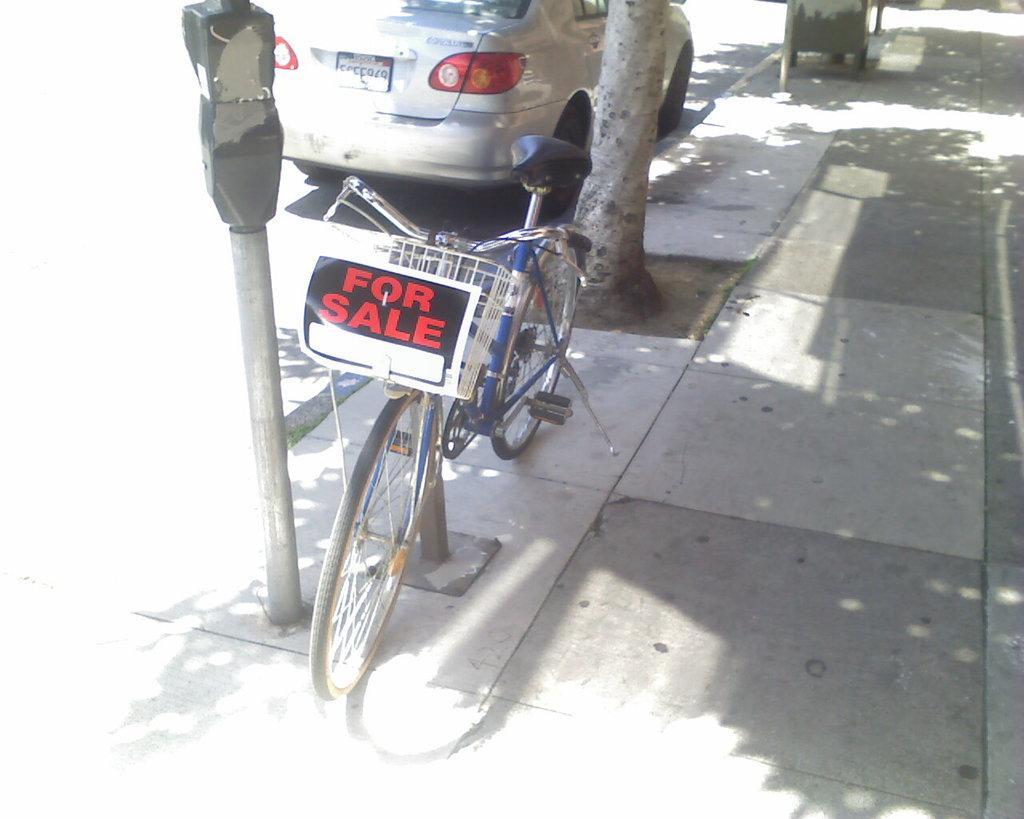Please provide a concise description of this image. In this image we can see a bicycle with a poster on the pavement and a car on the road, there is a parking meter beside the bicycle and there is a tree behind the bicycle. 